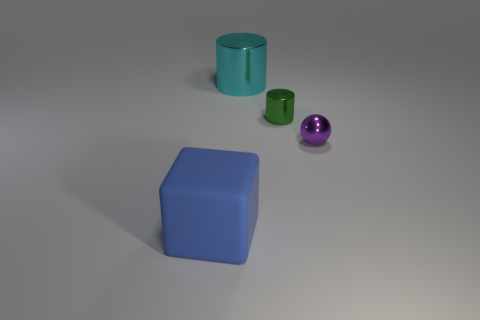Is the number of large cyan cylinders in front of the rubber object the same as the number of small spheres?
Make the answer very short. No. There is a large thing that is behind the small thing that is in front of the tiny green metal object; what number of rubber objects are behind it?
Make the answer very short. 0. There is a small thing behind the tiny purple sphere; what color is it?
Ensure brevity in your answer.  Green. There is a thing that is to the left of the tiny metal cylinder and behind the blue matte object; what material is it?
Make the answer very short. Metal. There is a large thing behind the big blue thing; what number of tiny purple objects are left of it?
Provide a short and direct response. 0. What shape is the cyan metallic thing?
Give a very brief answer. Cylinder. The purple object that is made of the same material as the green cylinder is what shape?
Provide a succinct answer. Sphere. There is a large object behind the blue rubber object; is its shape the same as the tiny green object?
Your answer should be compact. Yes. What shape is the large object in front of the purple ball?
Your answer should be compact. Cube. What number of blue cubes have the same size as the blue matte object?
Offer a terse response. 0. 